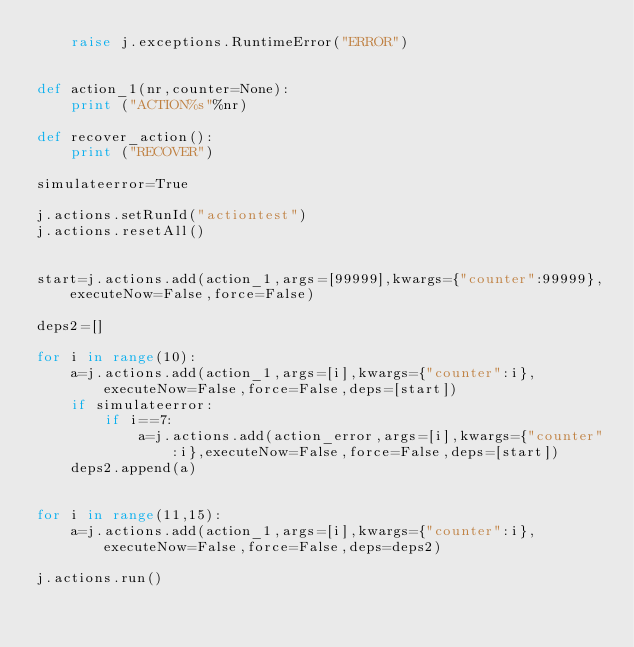<code> <loc_0><loc_0><loc_500><loc_500><_Python_>    raise j.exceptions.RuntimeError("ERROR")


def action_1(nr,counter=None):
    print ("ACTION%s"%nr)

def recover_action():
    print ("RECOVER")

simulateerror=True

j.actions.setRunId("actiontest")
j.actions.resetAll()


start=j.actions.add(action_1,args=[99999],kwargs={"counter":99999},executeNow=False,force=False)

deps2=[]

for i in range(10):
    a=j.actions.add(action_1,args=[i],kwargs={"counter":i},executeNow=False,force=False,deps=[start])
    if simulateerror:
        if i==7:
            a=j.actions.add(action_error,args=[i],kwargs={"counter":i},executeNow=False,force=False,deps=[start])
    deps2.append(a)


for i in range(11,15):
    a=j.actions.add(action_1,args=[i],kwargs={"counter":i},executeNow=False,force=False,deps=deps2)

j.actions.run()</code> 